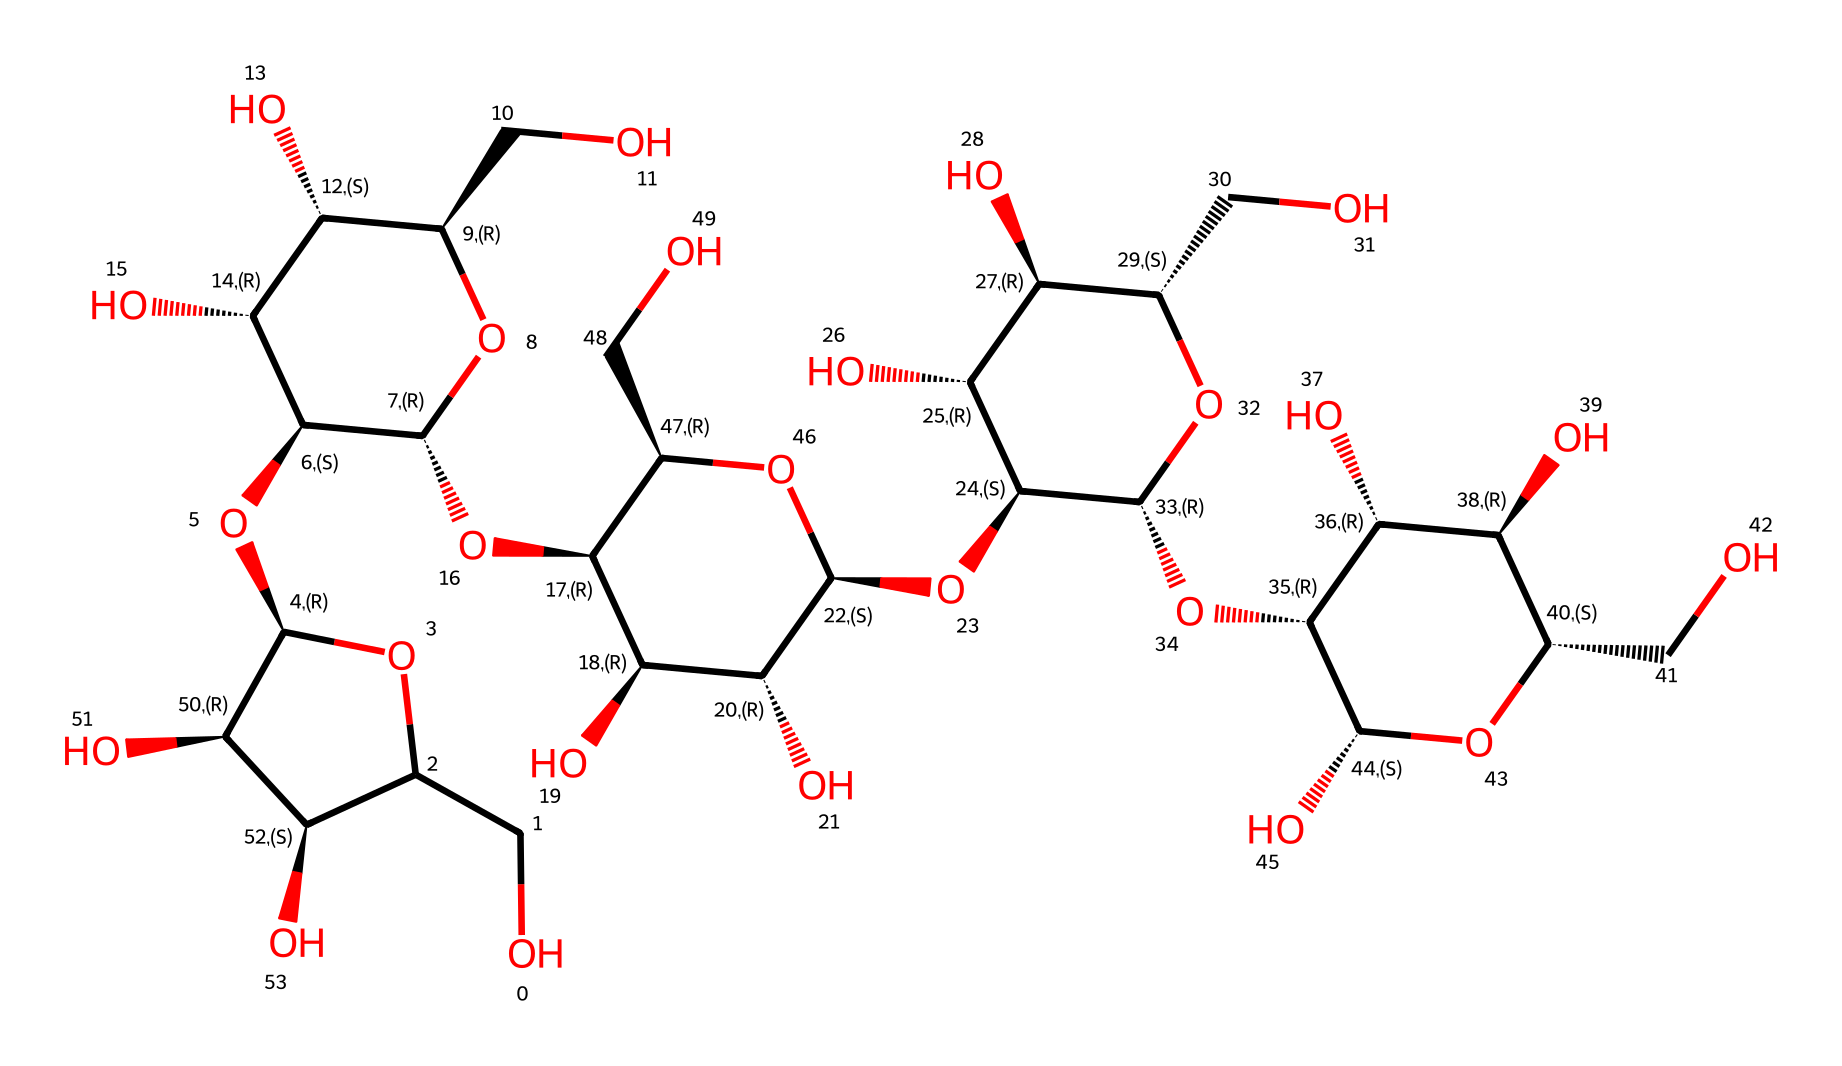What is the primary element in cellulose? Cellulose is primarily composed of carbon, hydrogen, and oxygen. The backbone of its structure is made of carbon atoms, which are bonded to hydroxyl (OH) groups and hydrogen atoms.
Answer: carbon How many oxygen atoms are present in the cellulose structure? To find the number of oxygen atoms, we can count the occurrences of the letter "O" in the SMILES representation. There are a total of 10 oxygen atoms identified in the structure.
Answer: 10 What type of biological macromolecule is cellulose? Cellulose is a polysaccharide, which is a type of carbohydrate. It consists of long chains of glucose units linked together, specifically through β-1,4-glycosidic bonds.
Answer: polysaccharide Does cellulose contain any nitrogen atoms? By analyzing the SMILES representation, it is evident that there are no nitrogen atoms present in the structure of cellulose. All atoms present belong to carbon, hydrogen, and oxygen.
Answer: no What is the most significant functional group in cellulose? The most significant functional group in cellulose is the hydroxyl (OH) group. These groups are responsible for the hydrogen bonding that gives cellulose its structural properties and solubility characteristics.
Answer: hydroxyl How many carbohydrate units are linked in the cellulose molecule? Cellulose is formed by the linkage of multiple glucose units. Each repeating unit in cellulose is a glucose molecule, and the number of units can be substantial, often ranging in the thousands. In a typical structure, we can see several glucose residue repetitions highlighted by the connectivity in the structure.
Answer: numerous 